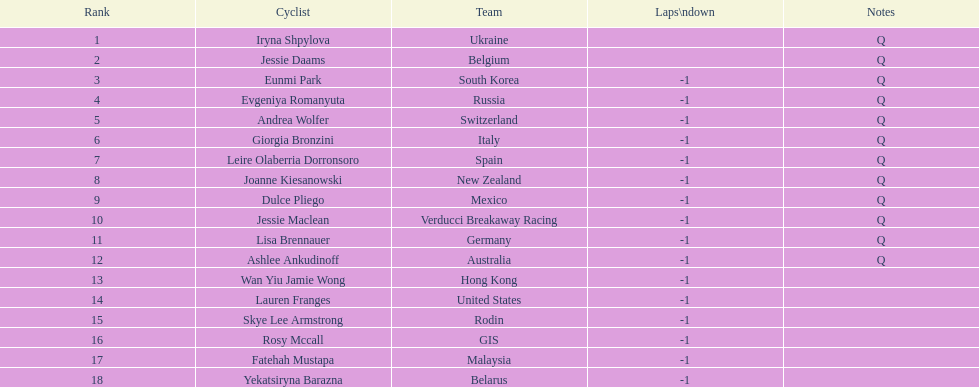How many cyclist do not have -1 laps down? 2. 